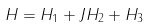Convert formula to latex. <formula><loc_0><loc_0><loc_500><loc_500>H = H _ { 1 } + J H _ { 2 } + H _ { 3 }</formula> 